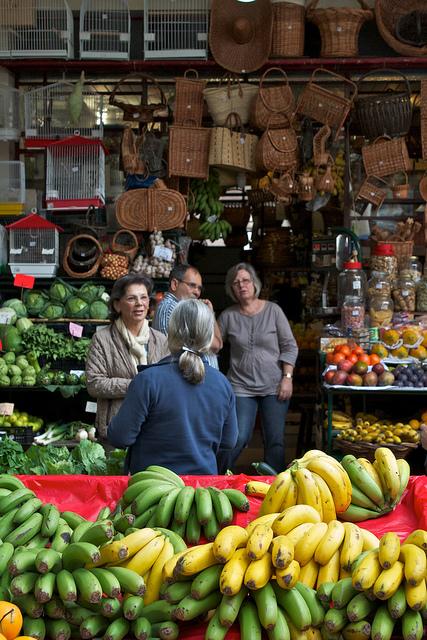Are the lights on or off?
Quick response, please. Off. Is everyone facing the camera?
Concise answer only. No. How many bunches of bananas appear in the photo?
Answer briefly. 15. How many baskets are being sold?
Short answer required. 20. Where are the green bananas?
Keep it brief. Upfront. 